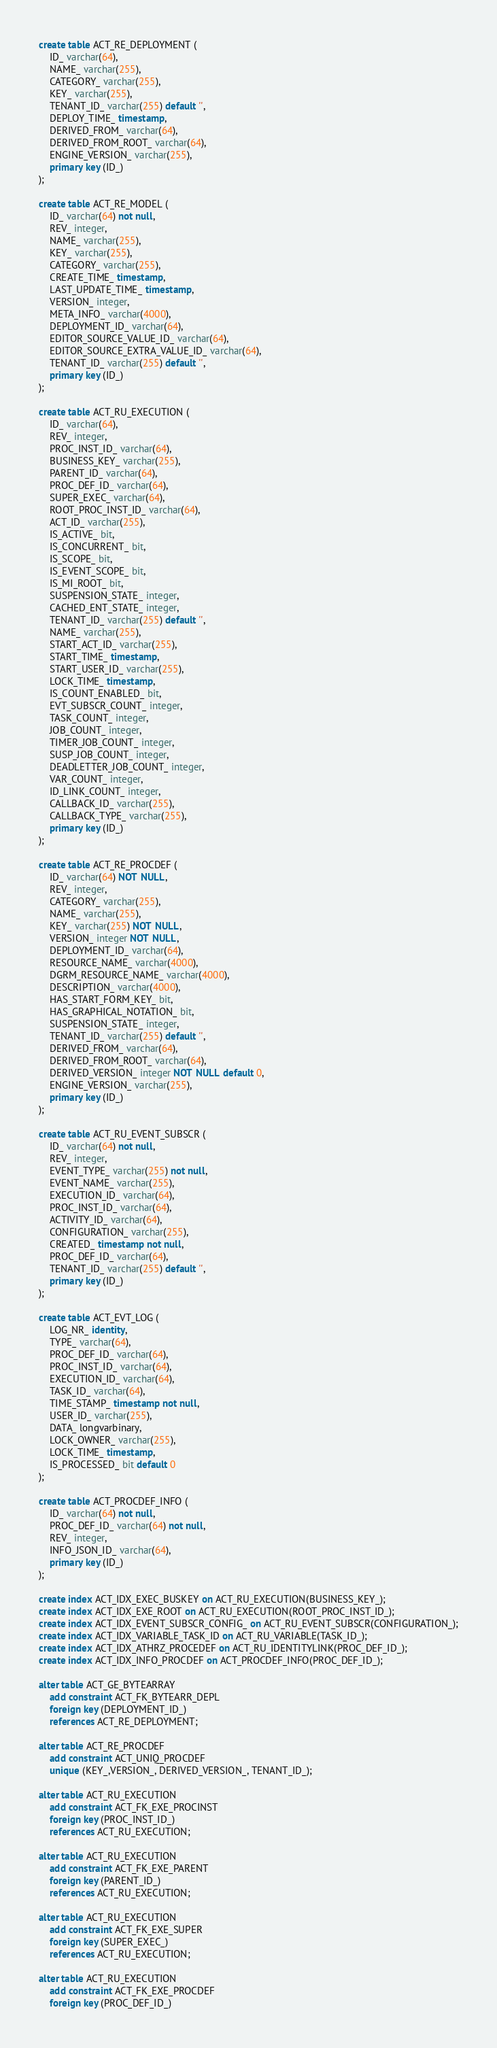<code> <loc_0><loc_0><loc_500><loc_500><_SQL_>create table ACT_RE_DEPLOYMENT (
    ID_ varchar(64),
    NAME_ varchar(255),
    CATEGORY_ varchar(255),
    KEY_ varchar(255),
    TENANT_ID_ varchar(255) default '',
    DEPLOY_TIME_ timestamp,
    DERIVED_FROM_ varchar(64),
    DERIVED_FROM_ROOT_ varchar(64),
    ENGINE_VERSION_ varchar(255),
    primary key (ID_)
);

create table ACT_RE_MODEL (
    ID_ varchar(64) not null,
    REV_ integer,
    NAME_ varchar(255),
    KEY_ varchar(255),
    CATEGORY_ varchar(255),
    CREATE_TIME_ timestamp,
    LAST_UPDATE_TIME_ timestamp,
    VERSION_ integer,
    META_INFO_ varchar(4000),
    DEPLOYMENT_ID_ varchar(64),
    EDITOR_SOURCE_VALUE_ID_ varchar(64),
    EDITOR_SOURCE_EXTRA_VALUE_ID_ varchar(64),
    TENANT_ID_ varchar(255) default '',
    primary key (ID_)
);

create table ACT_RU_EXECUTION (
    ID_ varchar(64),
    REV_ integer,
    PROC_INST_ID_ varchar(64),
    BUSINESS_KEY_ varchar(255),
    PARENT_ID_ varchar(64),
    PROC_DEF_ID_ varchar(64),
    SUPER_EXEC_ varchar(64),
    ROOT_PROC_INST_ID_ varchar(64),
    ACT_ID_ varchar(255),
    IS_ACTIVE_ bit,
    IS_CONCURRENT_ bit,
    IS_SCOPE_ bit,
    IS_EVENT_SCOPE_ bit,
    IS_MI_ROOT_ bit,
    SUSPENSION_STATE_ integer,
    CACHED_ENT_STATE_ integer,
    TENANT_ID_ varchar(255) default '',
    NAME_ varchar(255),
    START_ACT_ID_ varchar(255),
    START_TIME_ timestamp,
    START_USER_ID_ varchar(255),
    LOCK_TIME_ timestamp,
    IS_COUNT_ENABLED_ bit,
    EVT_SUBSCR_COUNT_ integer, 
    TASK_COUNT_ integer, 
    JOB_COUNT_ integer, 
    TIMER_JOB_COUNT_ integer,
    SUSP_JOB_COUNT_ integer,
    DEADLETTER_JOB_COUNT_ integer,
    VAR_COUNT_ integer, 
    ID_LINK_COUNT_ integer,
    CALLBACK_ID_ varchar(255),
    CALLBACK_TYPE_ varchar(255),
    primary key (ID_)
);

create table ACT_RE_PROCDEF (
    ID_ varchar(64) NOT NULL,
    REV_ integer,
    CATEGORY_ varchar(255),
    NAME_ varchar(255),
    KEY_ varchar(255) NOT NULL,
    VERSION_ integer NOT NULL,
    DEPLOYMENT_ID_ varchar(64),
    RESOURCE_NAME_ varchar(4000),
    DGRM_RESOURCE_NAME_ varchar(4000),
    DESCRIPTION_ varchar(4000),
    HAS_START_FORM_KEY_ bit,
    HAS_GRAPHICAL_NOTATION_ bit,
    SUSPENSION_STATE_ integer,
    TENANT_ID_ varchar(255) default '',
    DERIVED_FROM_ varchar(64),
    DERIVED_FROM_ROOT_ varchar(64),
    DERIVED_VERSION_ integer NOT NULL default 0,
    ENGINE_VERSION_ varchar(255),
    primary key (ID_)
);

create table ACT_RU_EVENT_SUBSCR (
    ID_ varchar(64) not null,
    REV_ integer,
    EVENT_TYPE_ varchar(255) not null,
    EVENT_NAME_ varchar(255),
    EXECUTION_ID_ varchar(64),
    PROC_INST_ID_ varchar(64),
    ACTIVITY_ID_ varchar(64),
    CONFIGURATION_ varchar(255),
    CREATED_ timestamp not null,
    PROC_DEF_ID_ varchar(64),
    TENANT_ID_ varchar(255) default '',
    primary key (ID_)
);

create table ACT_EVT_LOG (
    LOG_NR_ identity,
    TYPE_ varchar(64),
    PROC_DEF_ID_ varchar(64),
    PROC_INST_ID_ varchar(64),
    EXECUTION_ID_ varchar(64),
    TASK_ID_ varchar(64),
    TIME_STAMP_ timestamp not null,
    USER_ID_ varchar(255),
    DATA_ longvarbinary,
    LOCK_OWNER_ varchar(255),
    LOCK_TIME_ timestamp,
    IS_PROCESSED_ bit default 0
);

create table ACT_PROCDEF_INFO (
	ID_ varchar(64) not null,
    PROC_DEF_ID_ varchar(64) not null,
    REV_ integer,
    INFO_JSON_ID_ varchar(64),
    primary key (ID_)
);

create index ACT_IDX_EXEC_BUSKEY on ACT_RU_EXECUTION(BUSINESS_KEY_);
create index ACT_IDX_EXE_ROOT on ACT_RU_EXECUTION(ROOT_PROC_INST_ID_);
create index ACT_IDX_EVENT_SUBSCR_CONFIG_ on ACT_RU_EVENT_SUBSCR(CONFIGURATION_);
create index ACT_IDX_VARIABLE_TASK_ID on ACT_RU_VARIABLE(TASK_ID_);
create index ACT_IDX_ATHRZ_PROCEDEF on ACT_RU_IDENTITYLINK(PROC_DEF_ID_);
create index ACT_IDX_INFO_PROCDEF on ACT_PROCDEF_INFO(PROC_DEF_ID_);

alter table ACT_GE_BYTEARRAY
    add constraint ACT_FK_BYTEARR_DEPL
    foreign key (DEPLOYMENT_ID_)
    references ACT_RE_DEPLOYMENT;

alter table ACT_RE_PROCDEF
    add constraint ACT_UNIQ_PROCDEF
    unique (KEY_,VERSION_, DERIVED_VERSION_, TENANT_ID_);
    
alter table ACT_RU_EXECUTION
    add constraint ACT_FK_EXE_PROCINST
    foreign key (PROC_INST_ID_)
    references ACT_RU_EXECUTION;

alter table ACT_RU_EXECUTION
    add constraint ACT_FK_EXE_PARENT
    foreign key (PARENT_ID_)
    references ACT_RU_EXECUTION;
    
alter table ACT_RU_EXECUTION
    add constraint ACT_FK_EXE_SUPER 
    foreign key (SUPER_EXEC_) 
    references ACT_RU_EXECUTION;
    
alter table ACT_RU_EXECUTION
    add constraint ACT_FK_EXE_PROCDEF 
    foreign key (PROC_DEF_ID_) </code> 